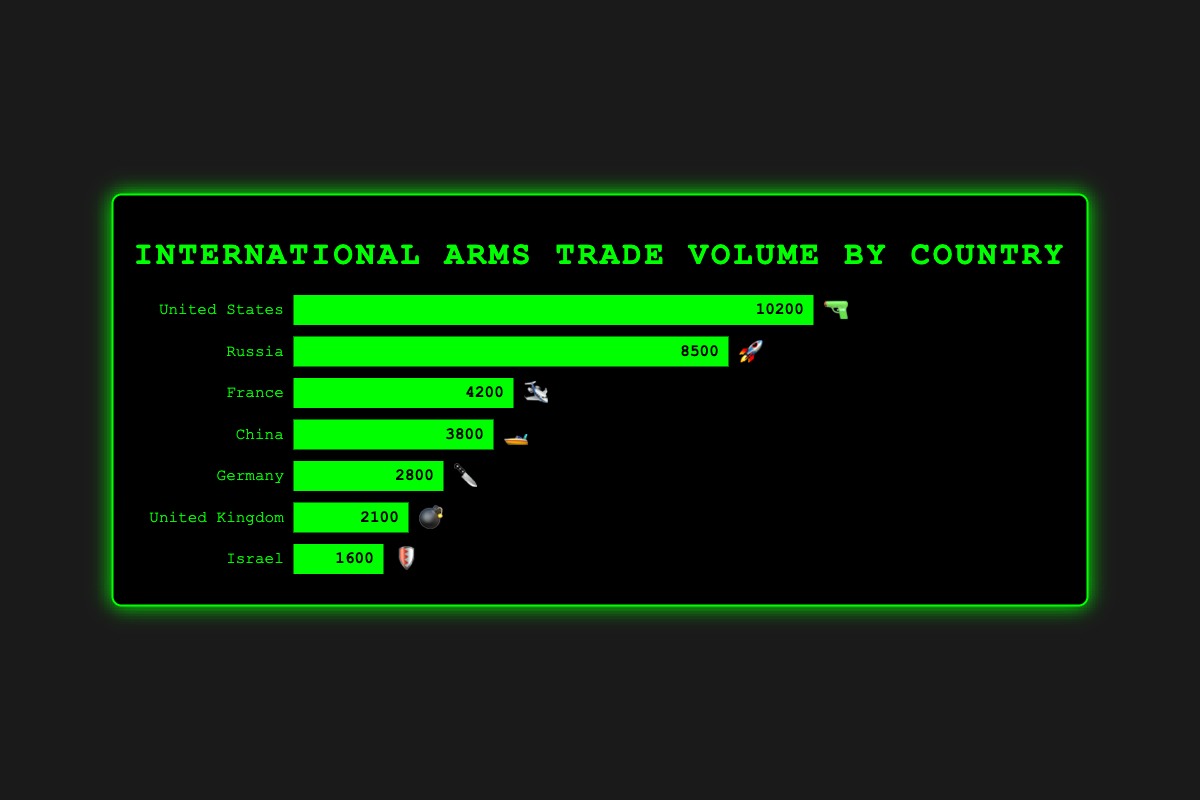What's the highest arms trade volume by country? The highest trade volume can be found by checking each bar's width value. The bar for the United States shows a volume of 10200, which is the highest among all countries.
Answer: 10200 How many countries are listed in this chart? To find the number of countries, count the number of bars or the number of country names listed. There are 7 countries in total.
Answer: 7 Which country has the smallest arms trade volume? To determine the country with the smallest volume, look for the shortest bar. The bar for Israel has a volume of 1600, which is the smallest among all countries.
Answer: Israel How does Russia's arms trade volume compare to China's? Russia's volume is 8500 and China's volume is 3800. Comparing these two numbers, Russia's volume is significantly higher than China's.
Answer: Russia's volume is higher What is the total arms trade volume for all countries combined? Add the volumes for all countries: 10200 (USA) + 8500 (Russia) + 4200 (France) + 3800 (China) + 2800 (Germany) + 2100 (UK) + 1600 (Israel). The total is 32400.
Answer: 32400 How much more is Germany's arms trade volume compared to the United Kingdom's? Germany's volume is 2800 and the UK's volume is 2100. The difference between them is 2800 - 2100 = 700. Germany's volume is 700 more than the UK's.
Answer: 700 Which country is represented by the emoji 💣? To find the emoji 💣, look at the labels next to each emoji. The United Kingdom has the 💣 emoji.
Answer: United Kingdom What is the average arms trade volume of France, China, and Germany combined? Add the volumes of France (4200), China (3800), and Germany (2800) and then divide by 3. The sum is 4200 + 3800 + 2800 = 10800. The average is 10800 / 3 = 3600.
Answer: 3600 If you were to rank the countries by arms trade volume, which country would be 3rd? Rank the countries by their volumes in descending order: USA (10200), Russia (8500), France (4200). So, France is 3rd in the list.
Answer: France What is the combined arms trade volume of the top two countries? The top two countries by volume are the United States (10200) and Russia (8500). Adding these together gives 10200 + 8500 = 18700.
Answer: 18700 